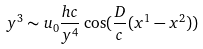Convert formula to latex. <formula><loc_0><loc_0><loc_500><loc_500>y ^ { 3 } \sim u _ { 0 } \frac { h c } { y ^ { 4 } } \cos ( \frac { D } { c } ( x ^ { 1 } - x ^ { 2 } ) )</formula> 